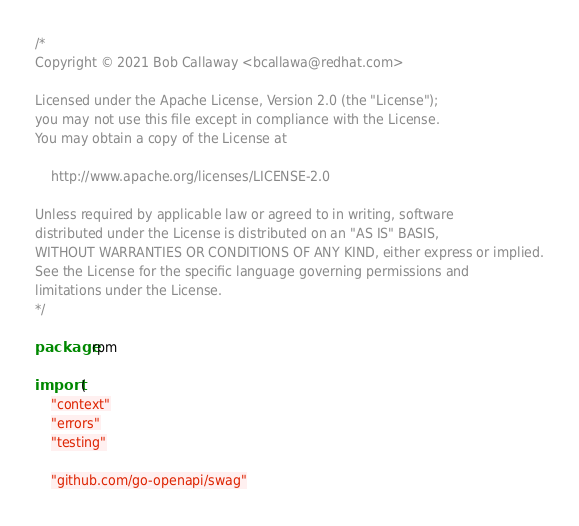Convert code to text. <code><loc_0><loc_0><loc_500><loc_500><_Go_>/*
Copyright © 2021 Bob Callaway <bcallawa@redhat.com>

Licensed under the Apache License, Version 2.0 (the "License");
you may not use this file except in compliance with the License.
You may obtain a copy of the License at

    http://www.apache.org/licenses/LICENSE-2.0

Unless required by applicable law or agreed to in writing, software
distributed under the License is distributed on an "AS IS" BASIS,
WITHOUT WARRANTIES OR CONDITIONS OF ANY KIND, either express or implied.
See the License for the specific language governing permissions and
limitations under the License.
*/

package rpm

import (
	"context"
	"errors"
	"testing"

	"github.com/go-openapi/swag"</code> 